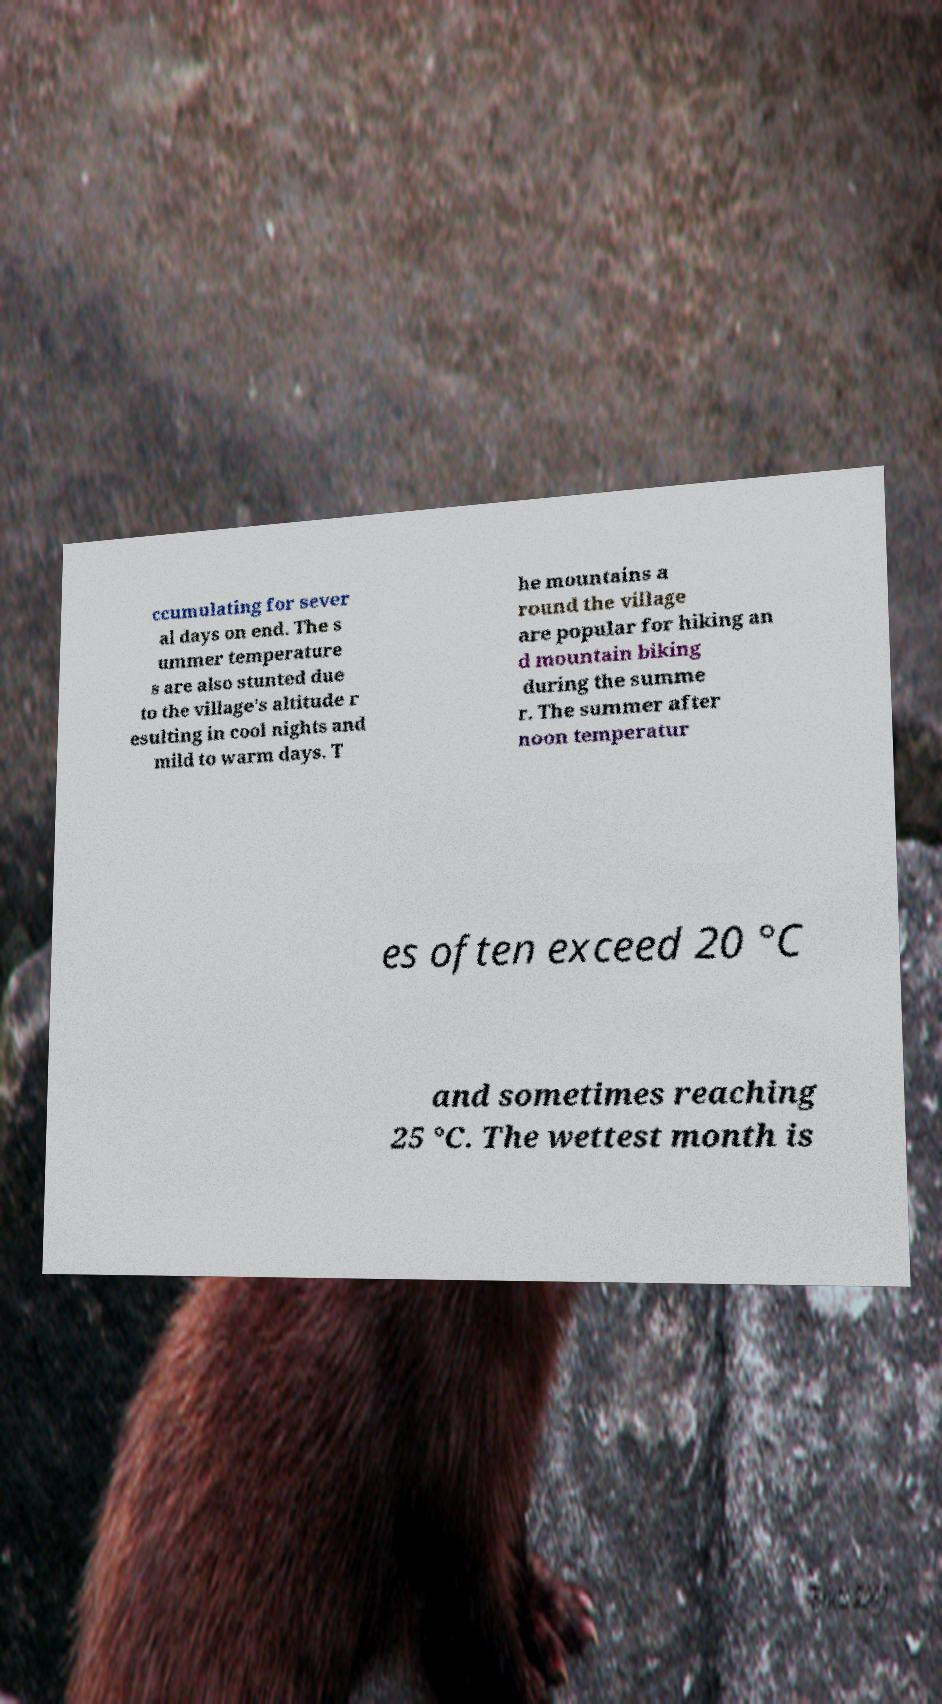What messages or text are displayed in this image? I need them in a readable, typed format. ccumulating for sever al days on end. The s ummer temperature s are also stunted due to the village's altitude r esulting in cool nights and mild to warm days. T he mountains a round the village are popular for hiking an d mountain biking during the summe r. The summer after noon temperatur es often exceed 20 °C and sometimes reaching 25 °C. The wettest month is 